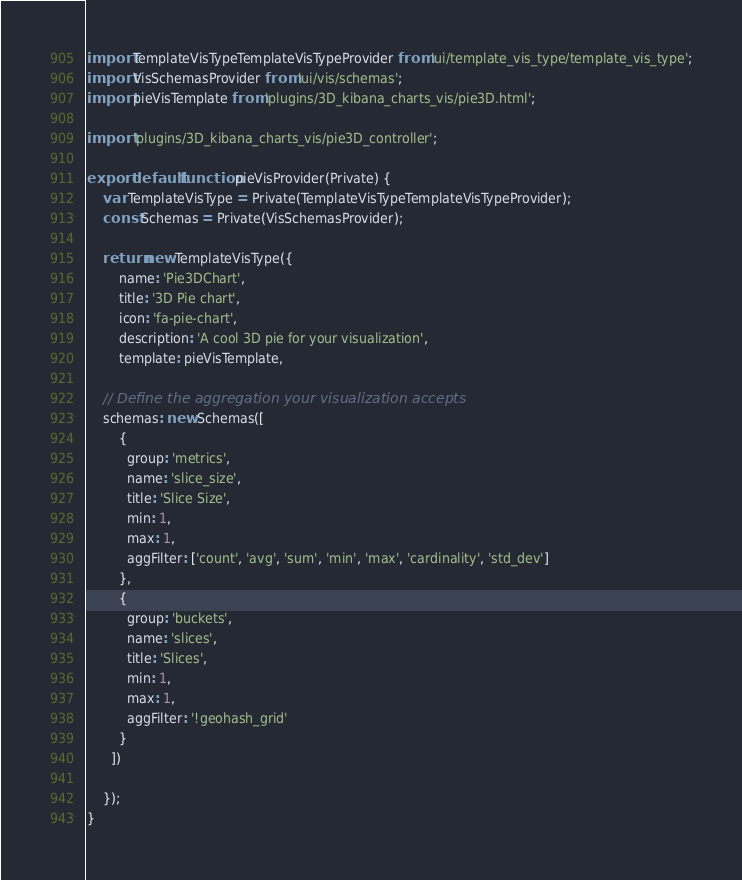<code> <loc_0><loc_0><loc_500><loc_500><_JavaScript_>import TemplateVisTypeTemplateVisTypeProvider from 'ui/template_vis_type/template_vis_type';
import VisSchemasProvider from 'ui/vis/schemas';
import pieVisTemplate from 'plugins/3D_kibana_charts_vis/pie3D.html';

import 'plugins/3D_kibana_charts_vis/pie3D_controller';

export default function pieVisProvider(Private) {
    var TemplateVisType = Private(TemplateVisTypeTemplateVisTypeProvider);
    const Schemas = Private(VisSchemasProvider);
	
    return new TemplateVisType({
  		name: 'Pie3DChart',
  		title: '3D Pie chart',
  		icon: 'fa-pie-chart',
  		description: 'A cool 3D pie for your visualization',
  		template: pieVisTemplate,

    // Define the aggregation your visualization accepts
    schemas: new Schemas([
        {
          group: 'metrics',
          name: 'slice_size',
          title: 'Slice Size',
          min: 1,
          max: 1,
          aggFilter: ['count', 'avg', 'sum', 'min', 'max', 'cardinality', 'std_dev']
        },
        {
          group: 'buckets',
          name: 'slices',
          title: 'Slices',
          min: 1,
          max: 1,
          aggFilter: '!geohash_grid'
        }
      ])

    });
}</code> 